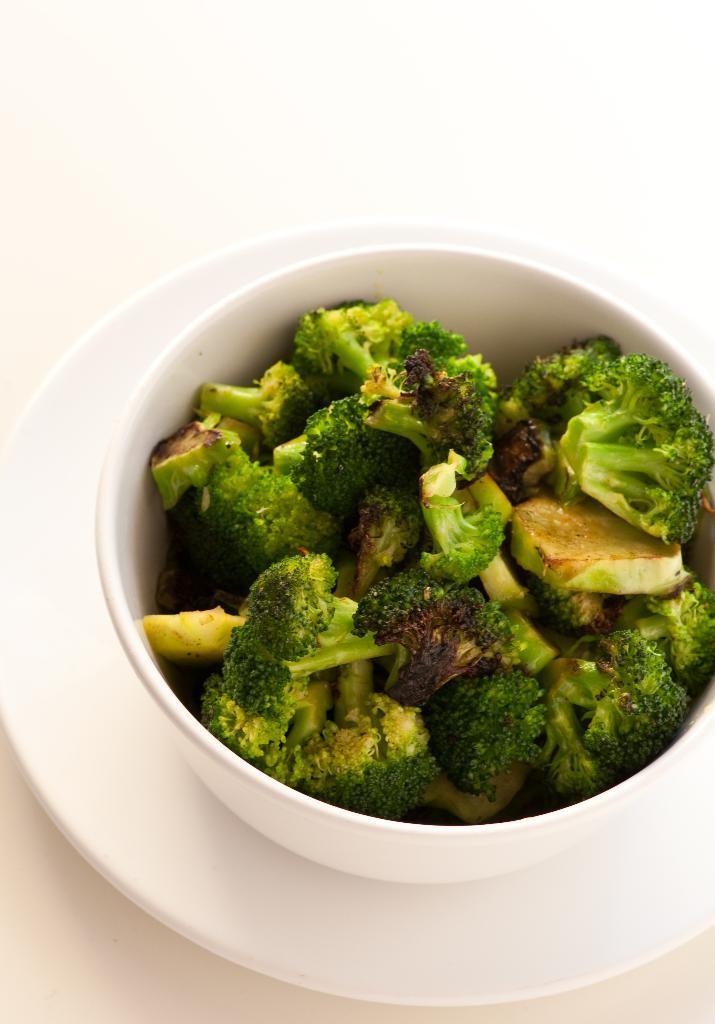Describe this image in one or two sentences. In this image we can see a broccoli in the bowl, here is the plate, and at back ground it is white. 